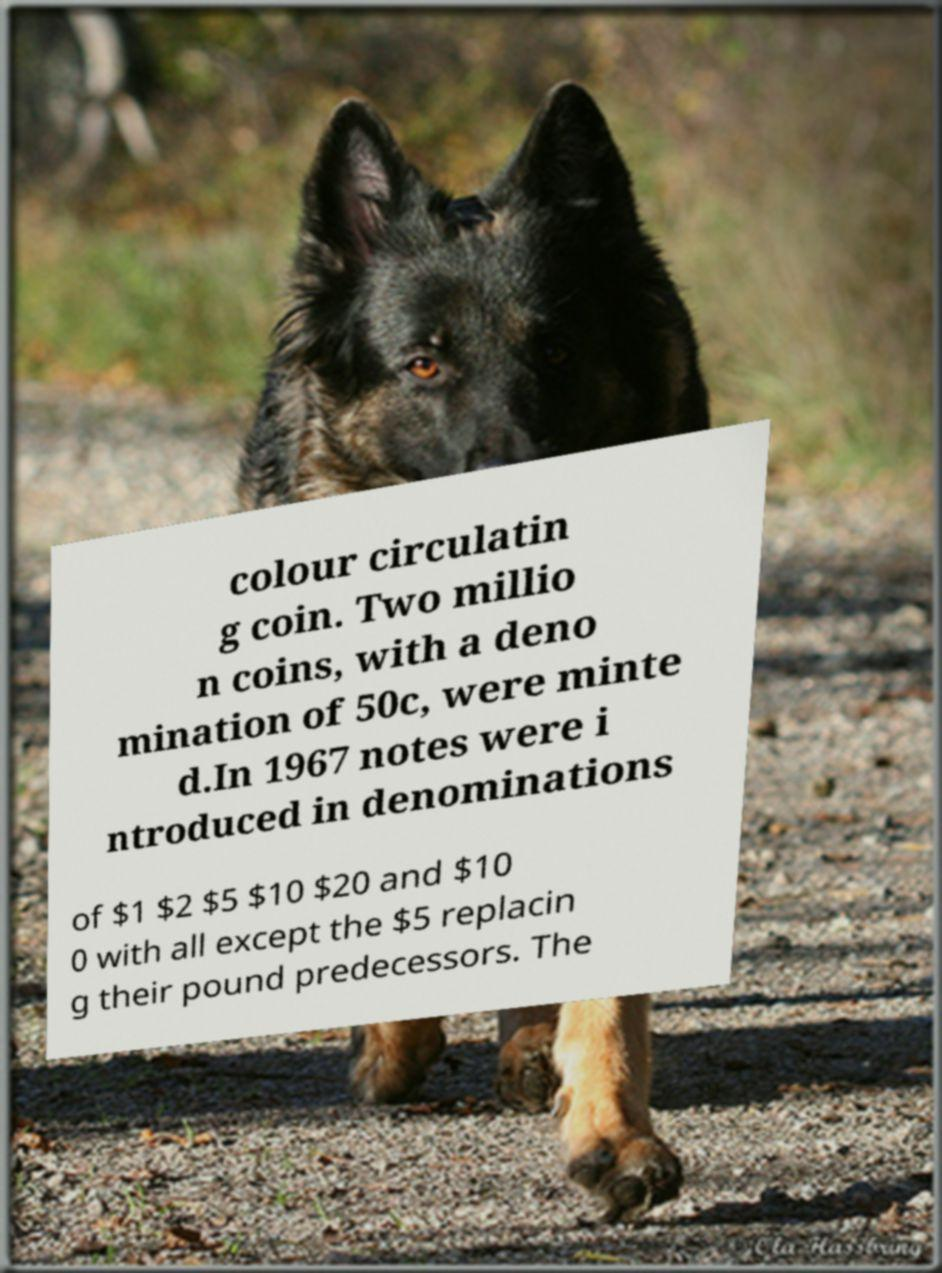Please read and relay the text visible in this image. What does it say? colour circulatin g coin. Two millio n coins, with a deno mination of 50c, were minte d.In 1967 notes were i ntroduced in denominations of $1 $2 $5 $10 $20 and $10 0 with all except the $5 replacin g their pound predecessors. The 